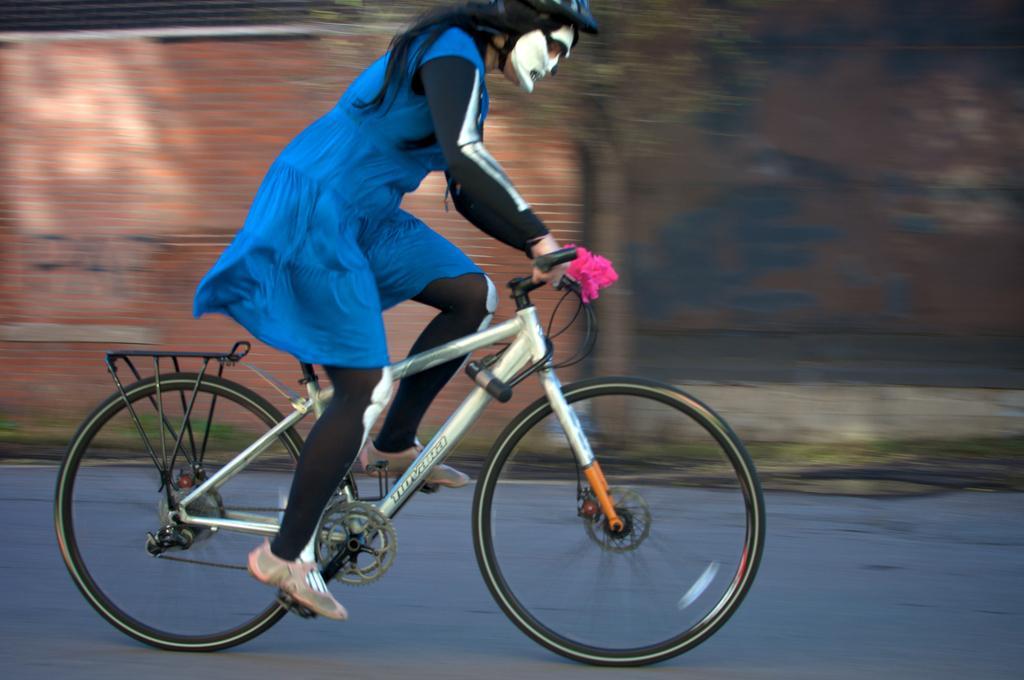Could you give a brief overview of what you see in this image? In this picture we can observe a person on the cycle. She is cycling a bicycle on the road. She is wearing blue color dress and helmet on her head. The background is completely blurred. 